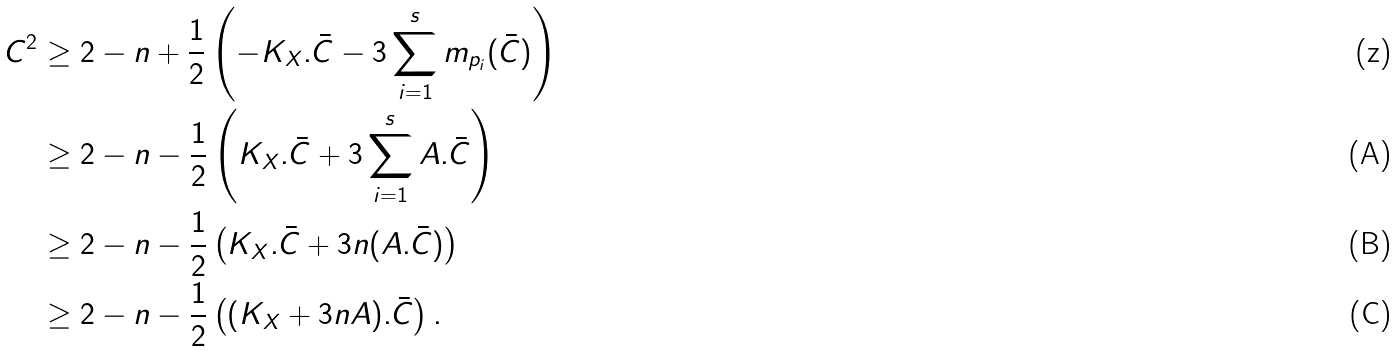Convert formula to latex. <formula><loc_0><loc_0><loc_500><loc_500>C ^ { 2 } & \geq 2 - n + \frac { 1 } { 2 } \left ( - K _ { X } . \bar { C } - 3 \sum _ { i = 1 } ^ { s } m _ { p _ { i } } ( \bar { C } ) \right ) \\ & \geq 2 - n - \frac { 1 } { 2 } \left ( K _ { X } . \bar { C } + 3 \sum _ { i = 1 } ^ { s } A . \bar { C } \right ) \\ & \geq 2 - n - \frac { 1 } { 2 } \left ( K _ { X } . \bar { C } + 3 n ( A . \bar { C } ) \right ) \\ & \geq 2 - n - \frac { 1 } { 2 } \left ( ( K _ { X } + 3 n A ) . \bar { C } \right ) .</formula> 